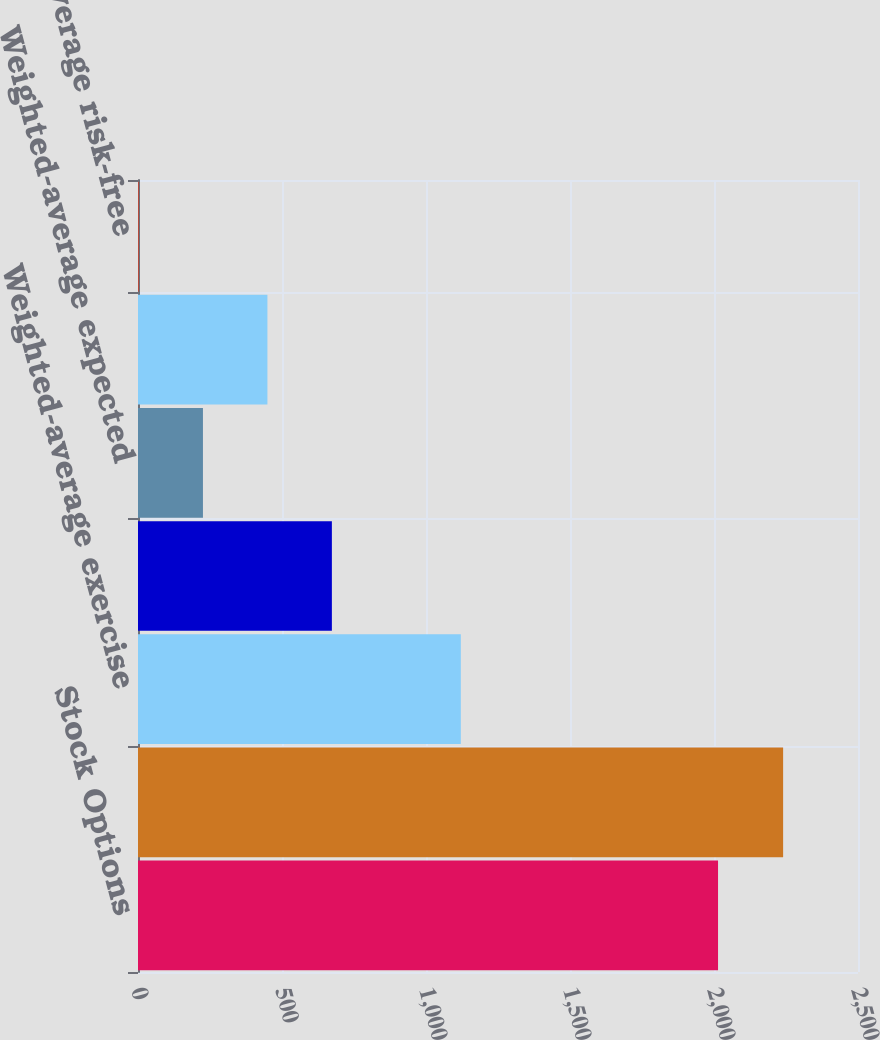<chart> <loc_0><loc_0><loc_500><loc_500><bar_chart><fcel>Stock Options<fcel>Options granted (in thousands)<fcel>Weighted-average exercise<fcel>Weighted-average grant-date<fcel>Weighted-average expected<fcel>Weighted-average expected term<fcel>Weighted-average risk-free<nl><fcel>2014<fcel>2240<fcel>1120.85<fcel>673.19<fcel>225.53<fcel>449.36<fcel>1.7<nl></chart> 